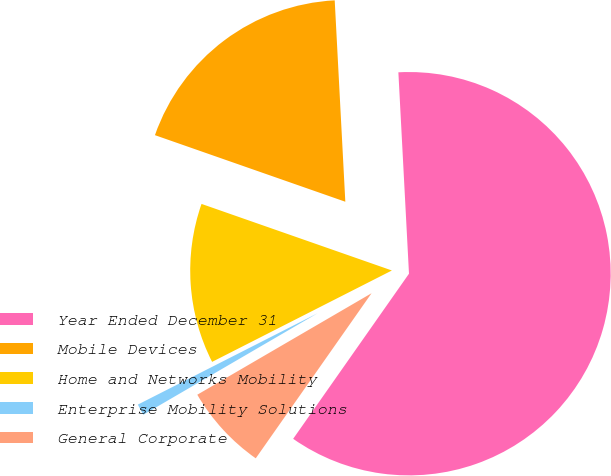Convert chart to OTSL. <chart><loc_0><loc_0><loc_500><loc_500><pie_chart><fcel>Year Ended December 31<fcel>Mobile Devices<fcel>Home and Networks Mobility<fcel>Enterprise Mobility Solutions<fcel>General Corporate<nl><fcel>60.58%<fcel>18.81%<fcel>12.84%<fcel>0.91%<fcel>6.87%<nl></chart> 